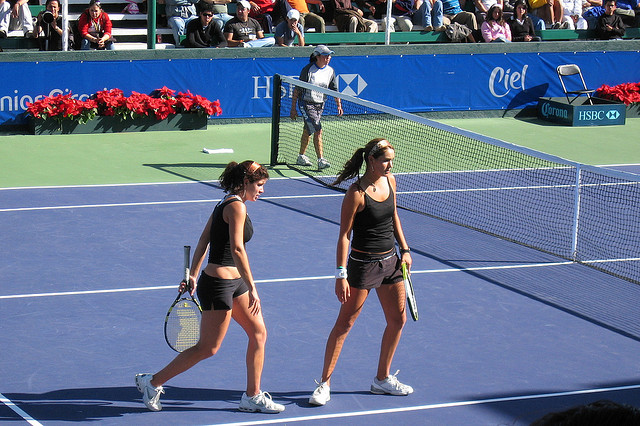Identify the text contained in this image. Ciel HSBC Corona H nios 